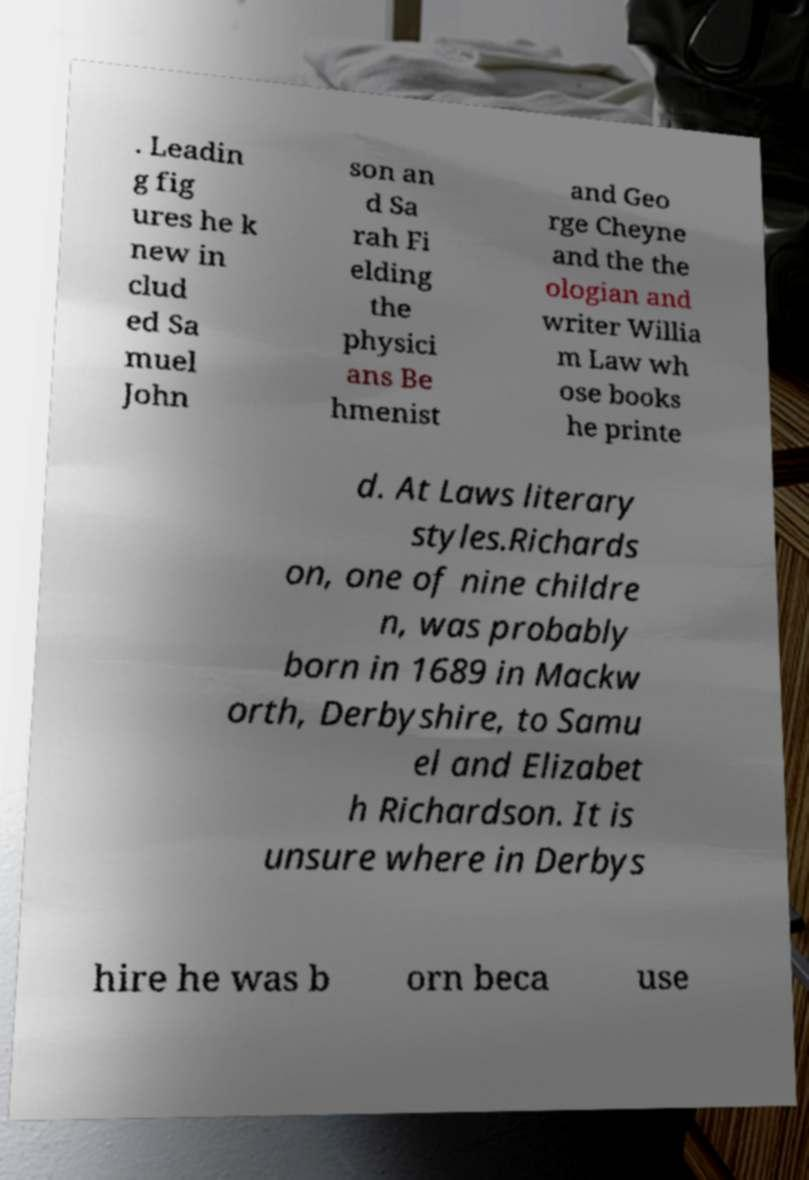Please identify and transcribe the text found in this image. . Leadin g fig ures he k new in clud ed Sa muel John son an d Sa rah Fi elding the physici ans Be hmenist and Geo rge Cheyne and the the ologian and writer Willia m Law wh ose books he printe d. At Laws literary styles.Richards on, one of nine childre n, was probably born in 1689 in Mackw orth, Derbyshire, to Samu el and Elizabet h Richardson. It is unsure where in Derbys hire he was b orn beca use 